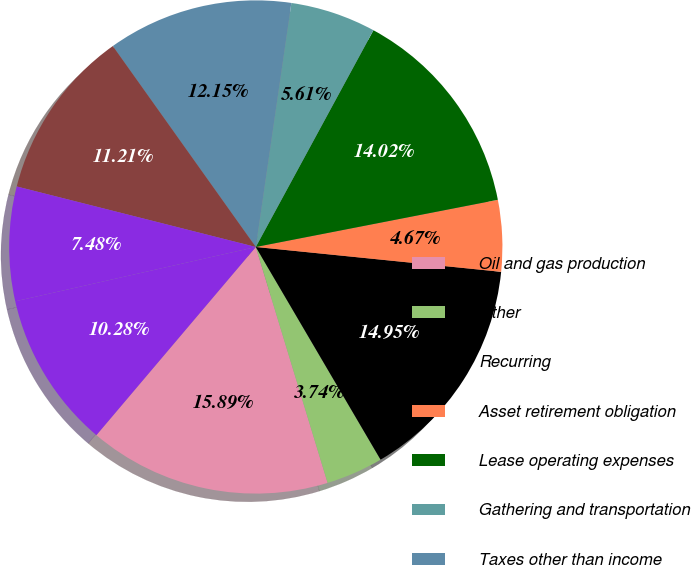Convert chart. <chart><loc_0><loc_0><loc_500><loc_500><pie_chart><fcel>Oil and gas production<fcel>Other<fcel>Recurring<fcel>Asset retirement obligation<fcel>Lease operating expenses<fcel>Gathering and transportation<fcel>Taxes other than income<fcel>General and administrative<fcel>Financing costs net<fcel>INCOME BEFORE INCOME TAXES<nl><fcel>15.89%<fcel>3.74%<fcel>14.95%<fcel>4.67%<fcel>14.02%<fcel>5.61%<fcel>12.15%<fcel>11.21%<fcel>7.48%<fcel>10.28%<nl></chart> 